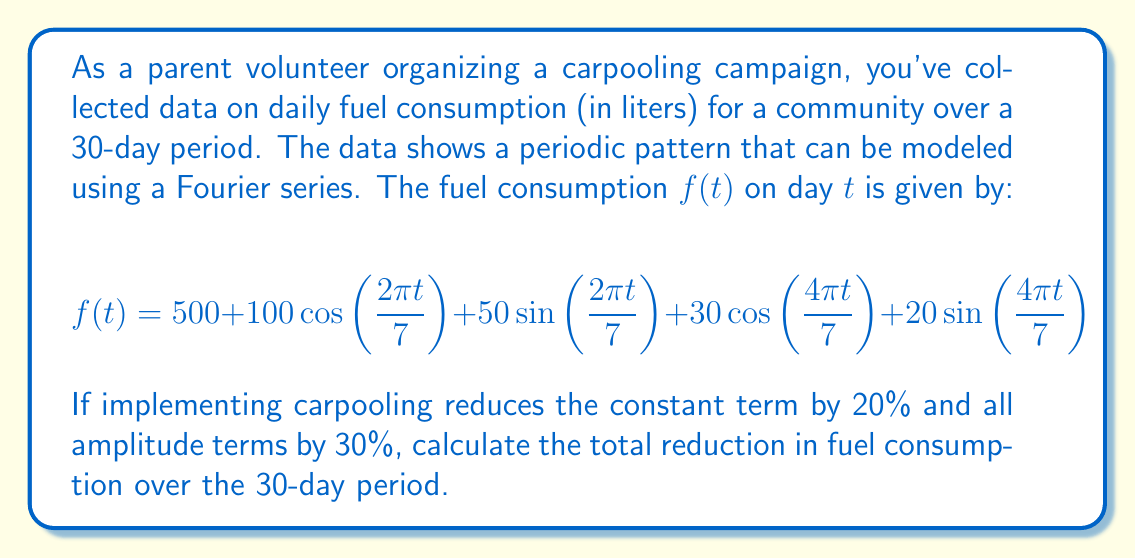Can you solve this math problem? To solve this problem, we'll follow these steps:

1) First, let's understand the given Fourier series:
   $$f(t) = 500 + 100\cos(\frac{2\pi t}{7}) + 50\sin(\frac{2\pi t}{7}) + 30\cos(\frac{4\pi t}{7}) + 20\sin(\frac{4\pi t}{7})$$
   
   Here, 500 is the constant term, and the rest are periodic terms with a fundamental period of 7 days.

2) After implementing carpooling, the new function $g(t)$ will be:
   $$g(t) = 400 + 70\cos(\frac{2\pi t}{7}) + 35\sin(\frac{2\pi t}{7}) + 21\cos(\frac{4\pi t}{7}) + 14\sin(\frac{4\pi t}{7})$$

3) To find the total reduction, we need to integrate the difference between $f(t)$ and $g(t)$ over the 30-day period:

   $$\text{Reduction} = \int_0^{30} [f(t) - g(t)] dt$$

4) Simplifying the integrand:
   $$f(t) - g(t) = 100 + 30\cos(\frac{2\pi t}{7}) + 15\sin(\frac{2\pi t}{7}) + 9\cos(\frac{4\pi t}{7}) + 6\sin(\frac{4\pi t}{7})$$

5) Now, let's integrate each term:
   
   - For the constant term: $\int_0^{30} 100 dt = 3000$
   
   - For the cosine and sine terms:
     $$\int_0^{30} 30\cos(\frac{2\pi t}{7}) dt = 30 \cdot \frac{7}{2\pi} \cdot \sin(\frac{2\pi t}{7}) \bigg|_0^{30} = 0$$
     $$\int_0^{30} 15\sin(\frac{2\pi t}{7}) dt = -15 \cdot \frac{7}{2\pi} \cdot \cos(\frac{2\pi t}{7}) \bigg|_0^{30} = 0$$
     
     Similarly, the integrals of the other periodic terms will also be zero.

6) Therefore, the total reduction is simply 3000 liters over the 30-day period.
Answer: The total reduction in fuel consumption over the 30-day period is 3000 liters. 